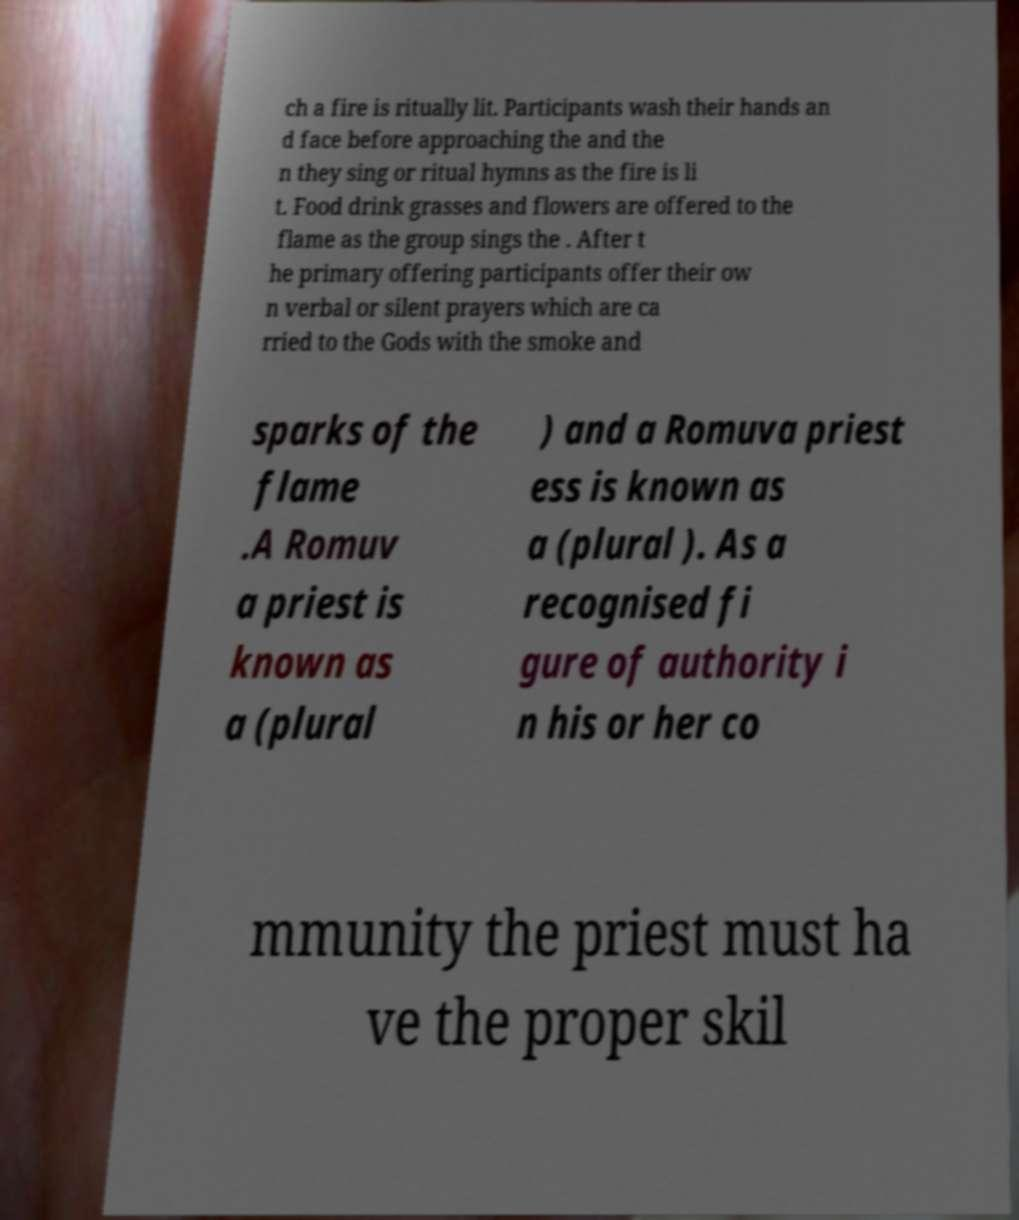Could you extract and type out the text from this image? ch a fire is ritually lit. Participants wash their hands an d face before approaching the and the n they sing or ritual hymns as the fire is li t. Food drink grasses and flowers are offered to the flame as the group sings the . After t he primary offering participants offer their ow n verbal or silent prayers which are ca rried to the Gods with the smoke and sparks of the flame .A Romuv a priest is known as a (plural ) and a Romuva priest ess is known as a (plural ). As a recognised fi gure of authority i n his or her co mmunity the priest must ha ve the proper skil 